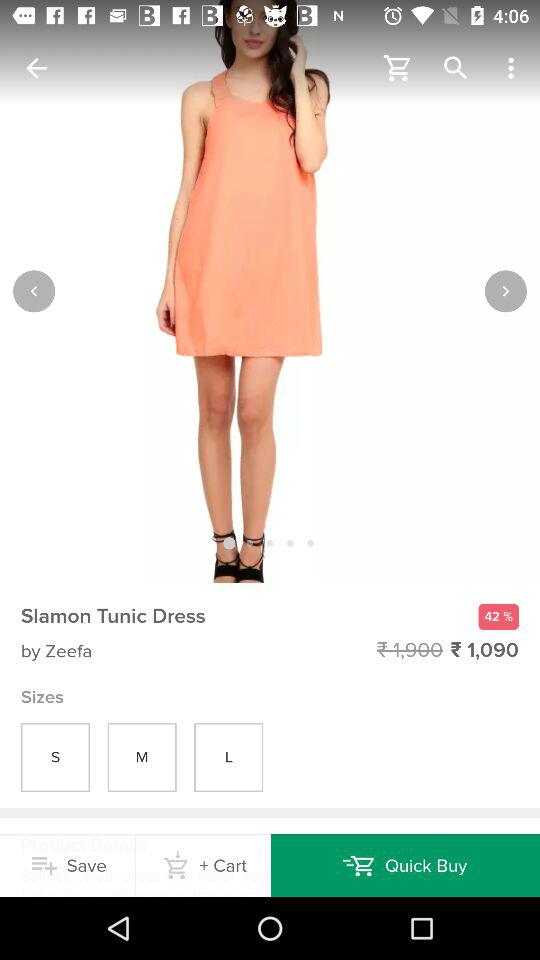What is the discount percentage? The discount percentage is 42. 